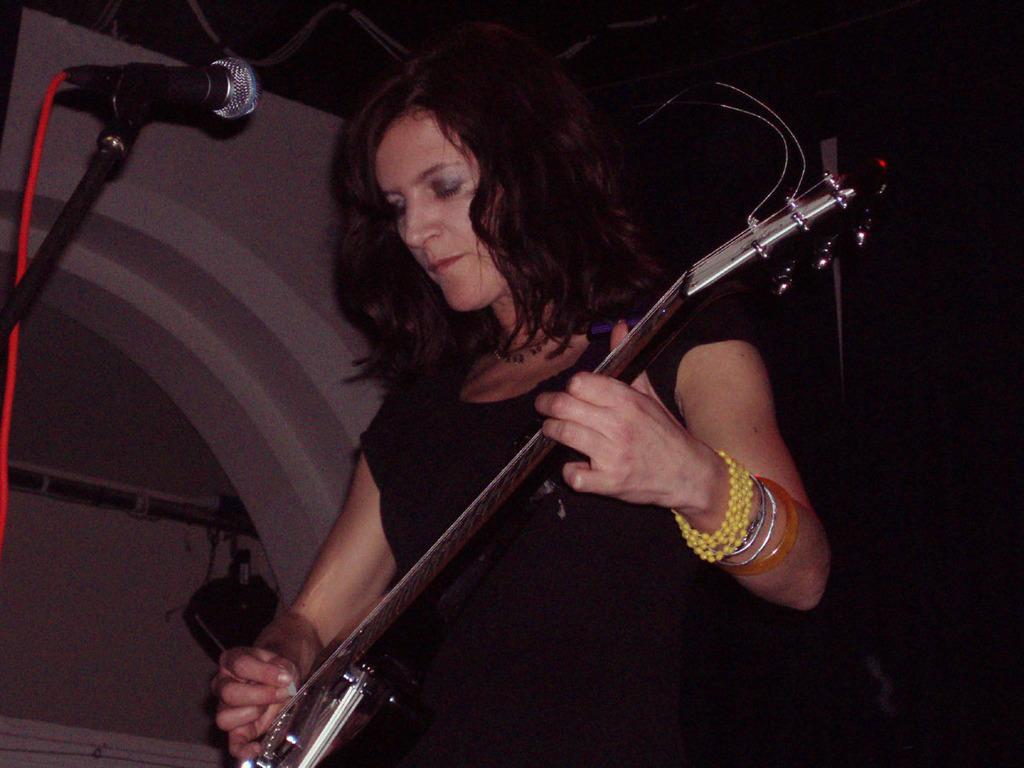How would you summarize this image in a sentence or two? A lady is playing guitar. She is wearing a black top. In front of her there is a mic. 